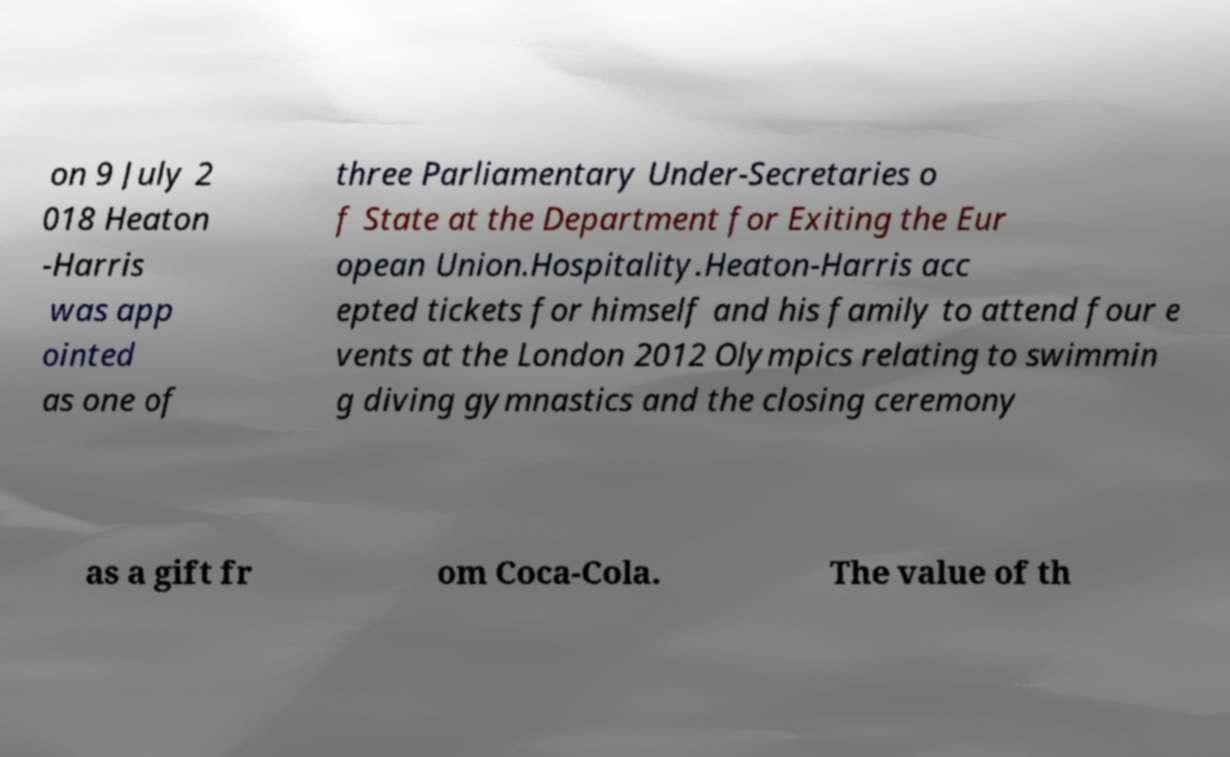Could you extract and type out the text from this image? on 9 July 2 018 Heaton -Harris was app ointed as one of three Parliamentary Under-Secretaries o f State at the Department for Exiting the Eur opean Union.Hospitality.Heaton-Harris acc epted tickets for himself and his family to attend four e vents at the London 2012 Olympics relating to swimmin g diving gymnastics and the closing ceremony as a gift fr om Coca-Cola. The value of th 